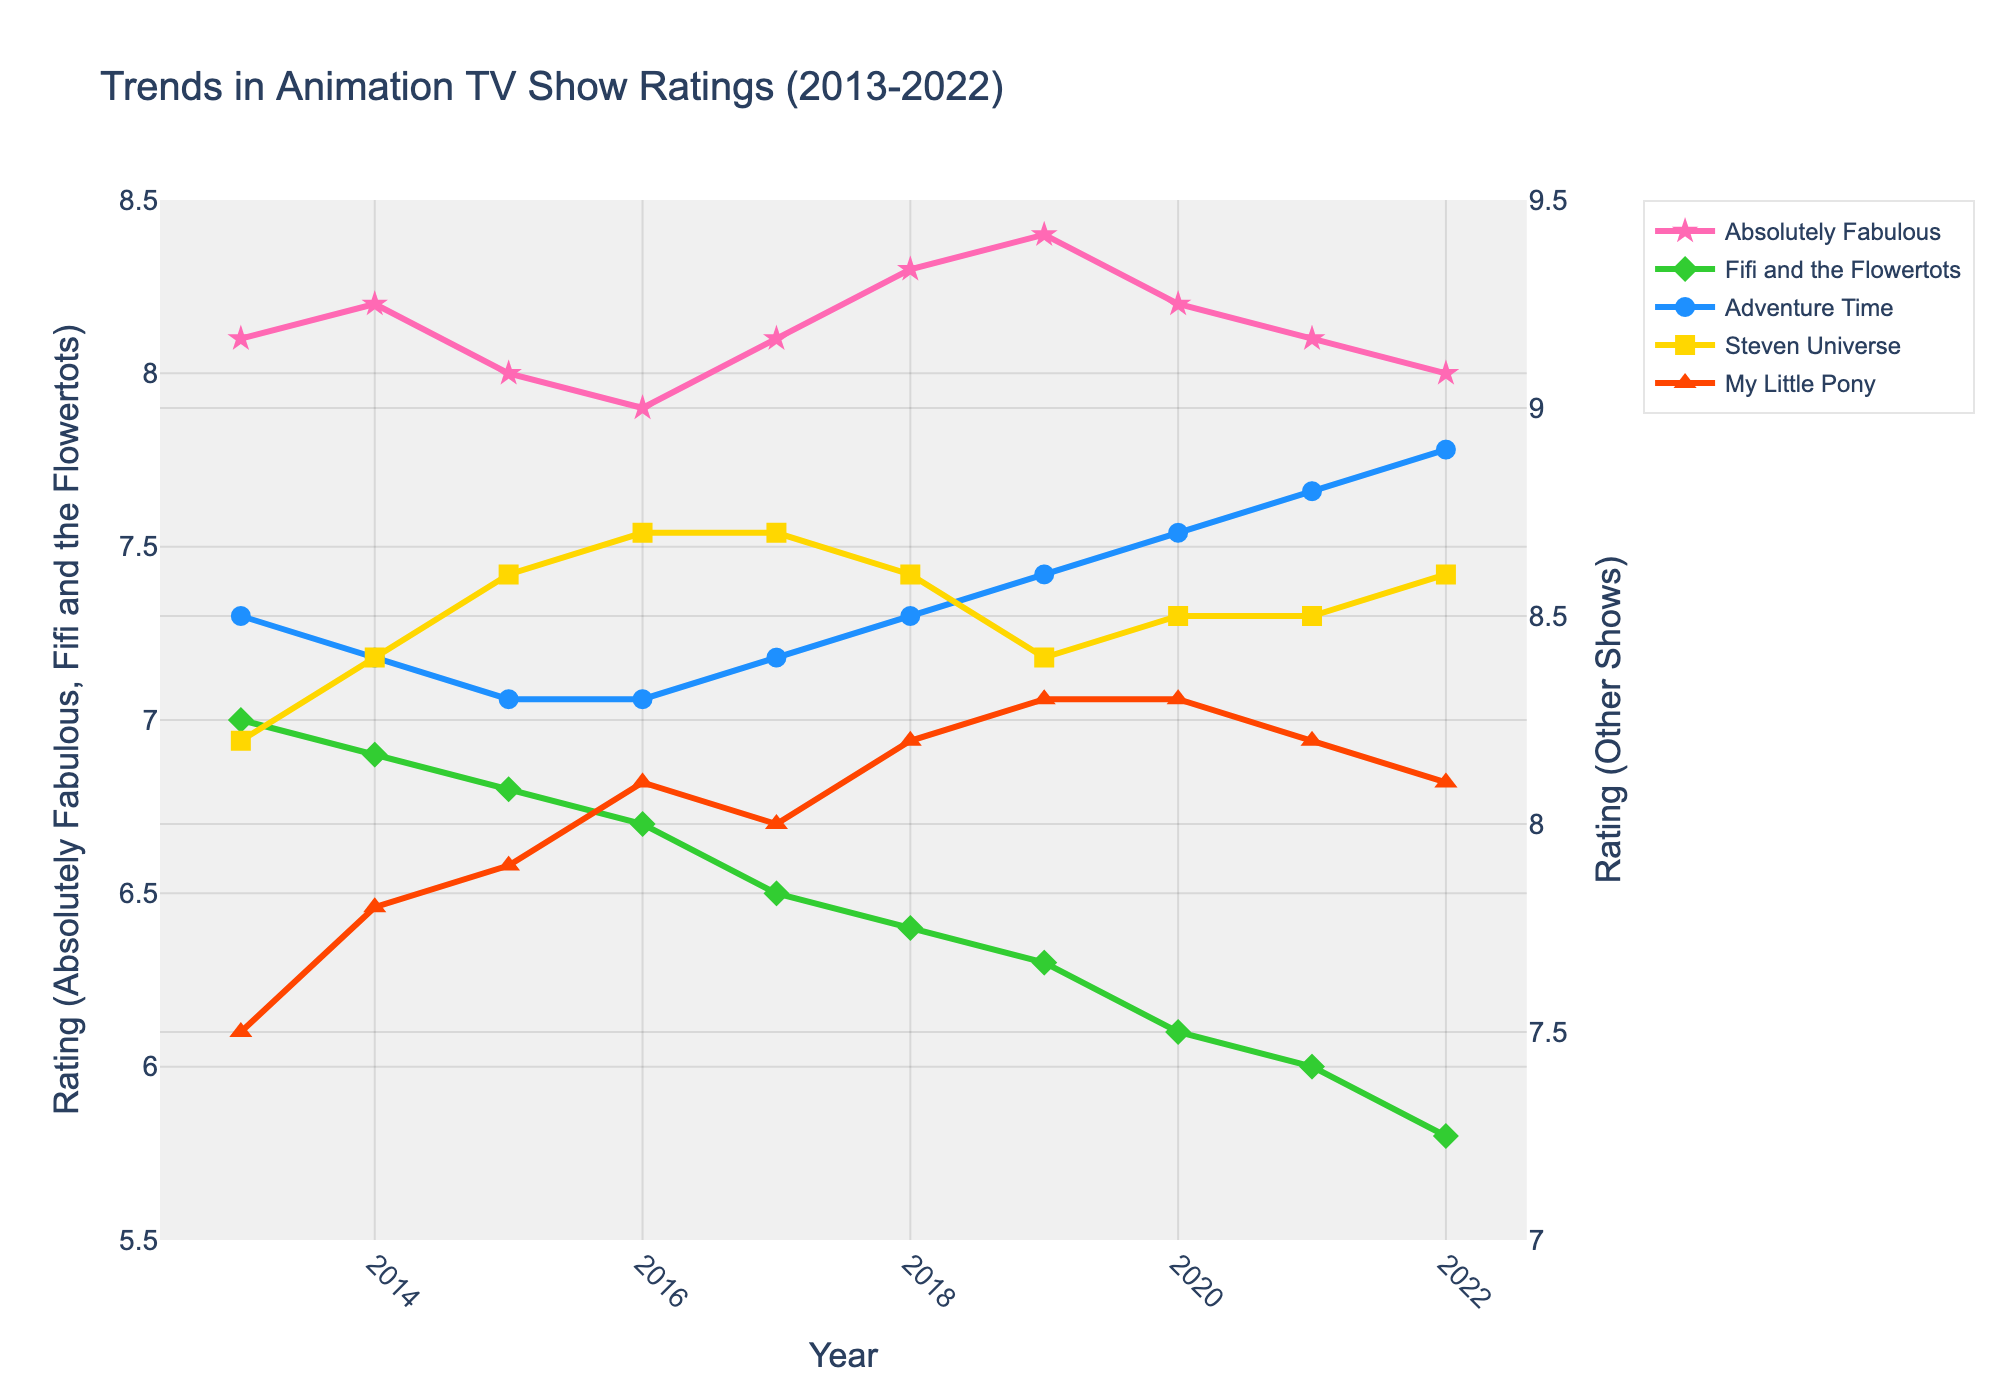What is the overall trend for the ratings of "Absolutely Fabulous" from 2013 to 2022? The ratings of "Absolutely Fabulous" show a slight fluctuation but generally remain relatively stable over the years. The rating starts at 8.1 in 2013, peaks in 2019 at 8.4, and falls back to 8.0 in 2022.
Answer: Relatively stable Which year shows the lowest rating for "Fifi and the Flowertots"? The lowest rating for "Fifi and the Flowertots" is observed in 2022 with a rating of 5.8. This can be seen by identifying the lowest point on the Fifi and the Flowertots rating line.
Answer: 2022 Between which consecutive years did "Adventure Time" show the most significant increase in ratings? The most significant increase in ratings for "Adventure Time" occurs between 2021 and 2022, where the rating increases from 8.8 to 8.9. This is identified by comparing the yearly increments in the rating line.
Answer: 2021-2022 Compare the rating trends of "Steven Universe" and "Absolutely Fabulous". How do they differ? "Steven Universe" shows an overall increasing trend from 8.2 in 2013 to 8.6 in 2022 with some fluctuations, while "Absolutely Fabulous" remains relatively stable with minor fluctuations between 7.9 and 8.4 over the same period.
Answer: Steven Universe is increasing, Absolutely Fabulous is stable What is the average rating for "My Little Pony" from 2013 to 2022? To find the average rating for "My Little Pony", sum up all the yearly ratings (7.5 + 7.8 + 7.9 + 8.1 + 8.0 + 8.2 + 8.3 + 8.3 + 8.2 + 8.1) and divide by the number of years (10). The calculation is (78.4 / 10).
Answer: 7.84 Which show had the highest rating in 2018? To determine this, compare the ratings of all shows in 2018. "Adventure Time" had the highest rating in 2018 with a rating of 8.5.
Answer: Adventure Time How did the ratings of "Fifi and the Flowertots" change from 2013 to 2022? The ratings of "Fifi and the Flowertots" consistently decreased over the years, starting from 7.0 in 2013 down to 5.8 in 2022.
Answer: Decreased Which show consistently had a high rating above 8.0 from 2013 to 2022? Both "Adventure Time" and "Steven Universe" had ratings consistently above 8.0 across all years from 2013 to 2022. This is identified by checking the rating lines that do not dip below 8.0.
Answer: Adventure Time and Steven Universe What was the highest rating attained by any show and in which year did it occur? The highest rating attained was 8.9 by "Adventure Time" in 2022. This can be seen by identifying the peak point across all show rating lines.
Answer: 8.9 in 2022 Which show had the more volatile rating, "Steven Universe" or "My Little Pony"? "Steven Universe" exhibited more fluctuations in its ratings, starting at 8.2 in 2013, peaking at 8.7 in 2016 and 2017, and ending at 8.6 in 2022. "My Little Pony" showed more stability with ratings ranging between 7.5 and 8.3.
Answer: Steven Universe 